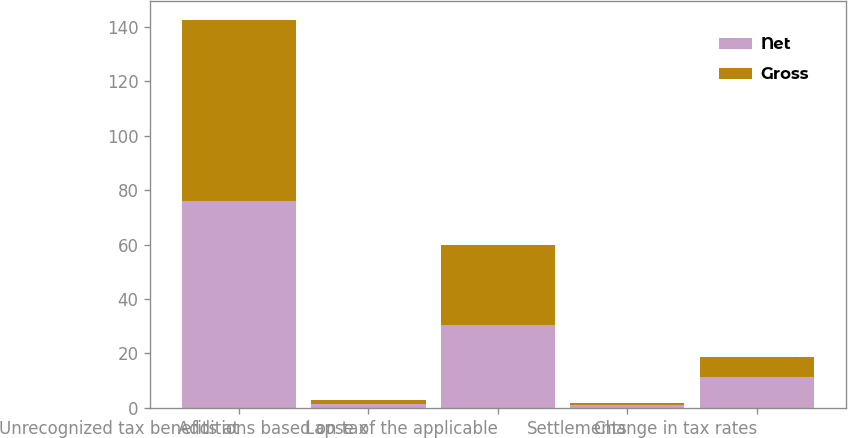Convert chart to OTSL. <chart><loc_0><loc_0><loc_500><loc_500><stacked_bar_chart><ecel><fcel>Unrecognized tax benefits at<fcel>Additions based on tax<fcel>Lapse of the applicable<fcel>Settlements<fcel>Change in tax rates<nl><fcel>Net<fcel>76.2<fcel>1.5<fcel>30.6<fcel>1<fcel>11.2<nl><fcel>Gross<fcel>66.3<fcel>1.4<fcel>29.1<fcel>0.9<fcel>7.4<nl></chart> 